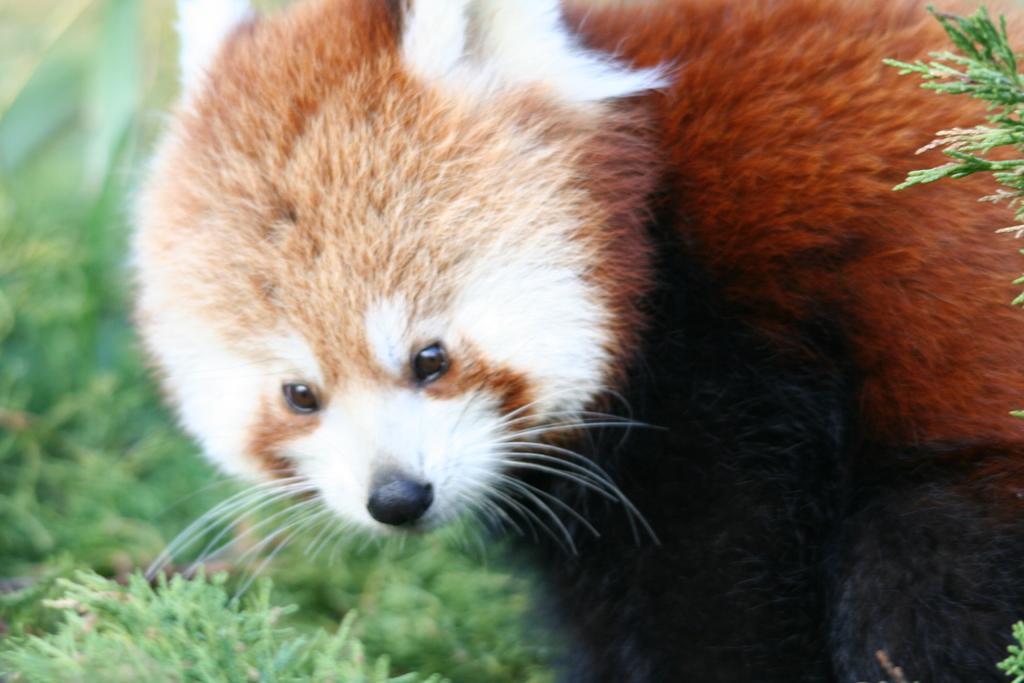Describe this image in one or two sentences. In this image I can see an animal which is in brown, black and white color. It is on the grass. 